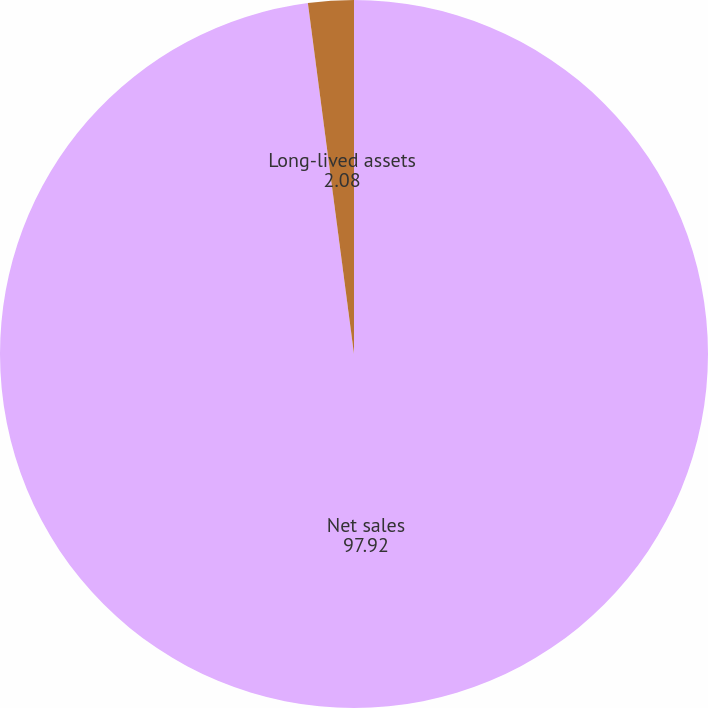Convert chart to OTSL. <chart><loc_0><loc_0><loc_500><loc_500><pie_chart><fcel>Net sales<fcel>Long-lived assets<nl><fcel>97.92%<fcel>2.08%<nl></chart> 